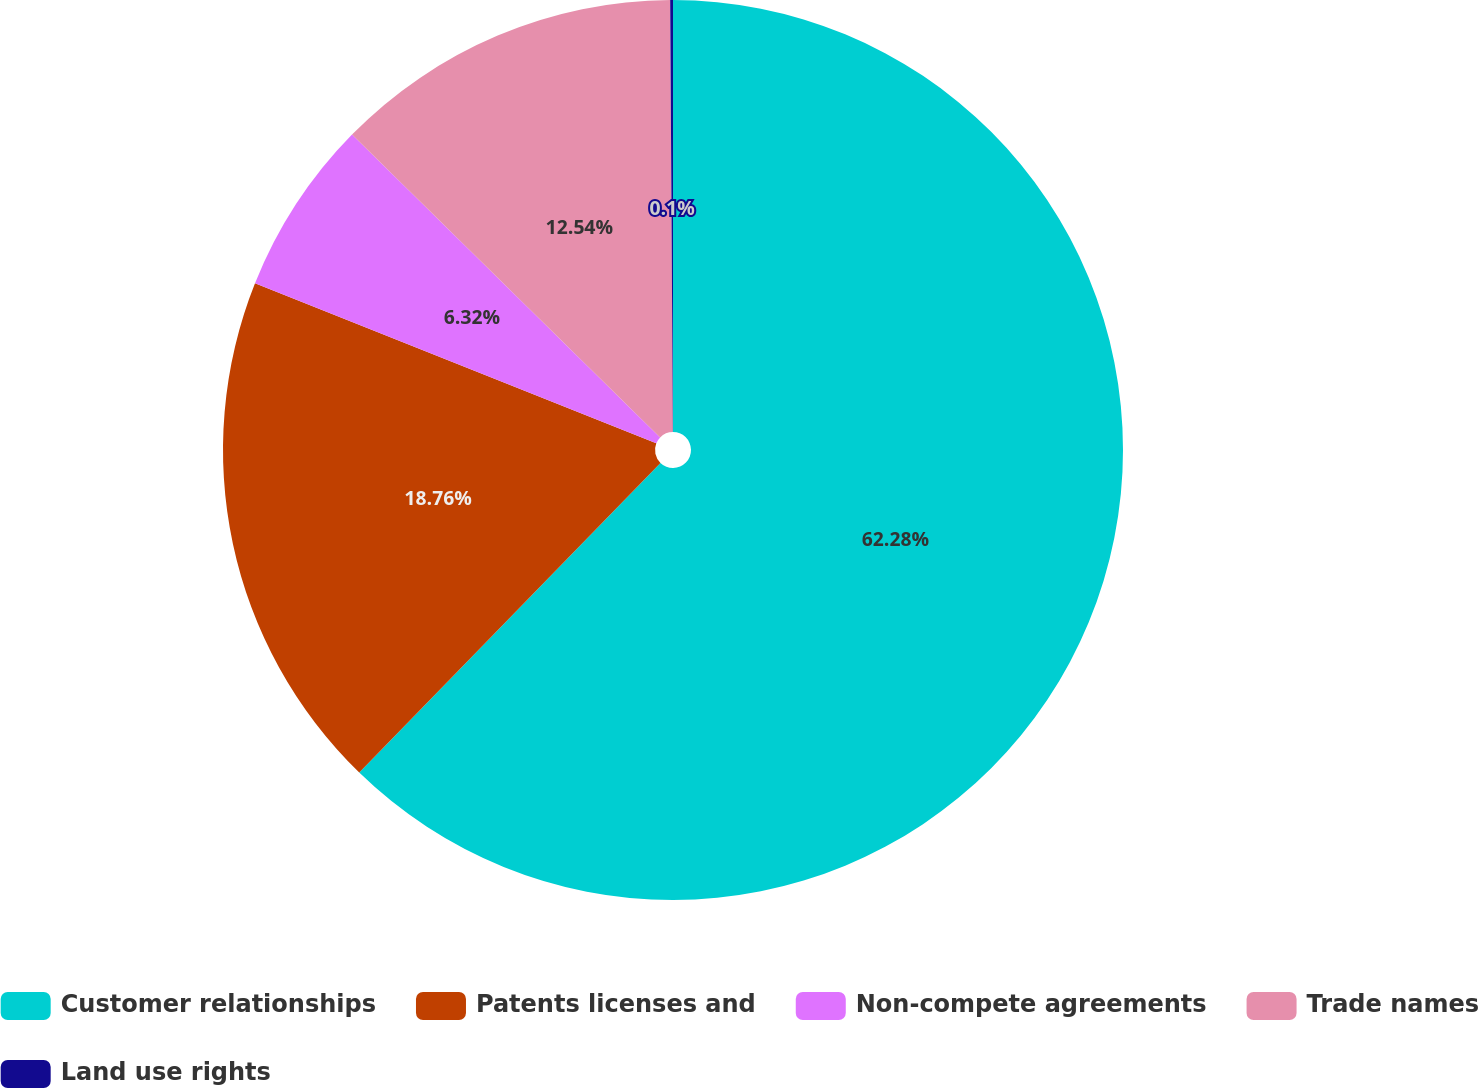Convert chart to OTSL. <chart><loc_0><loc_0><loc_500><loc_500><pie_chart><fcel>Customer relationships<fcel>Patents licenses and<fcel>Non-compete agreements<fcel>Trade names<fcel>Land use rights<nl><fcel>62.28%<fcel>18.76%<fcel>6.32%<fcel>12.54%<fcel>0.1%<nl></chart> 